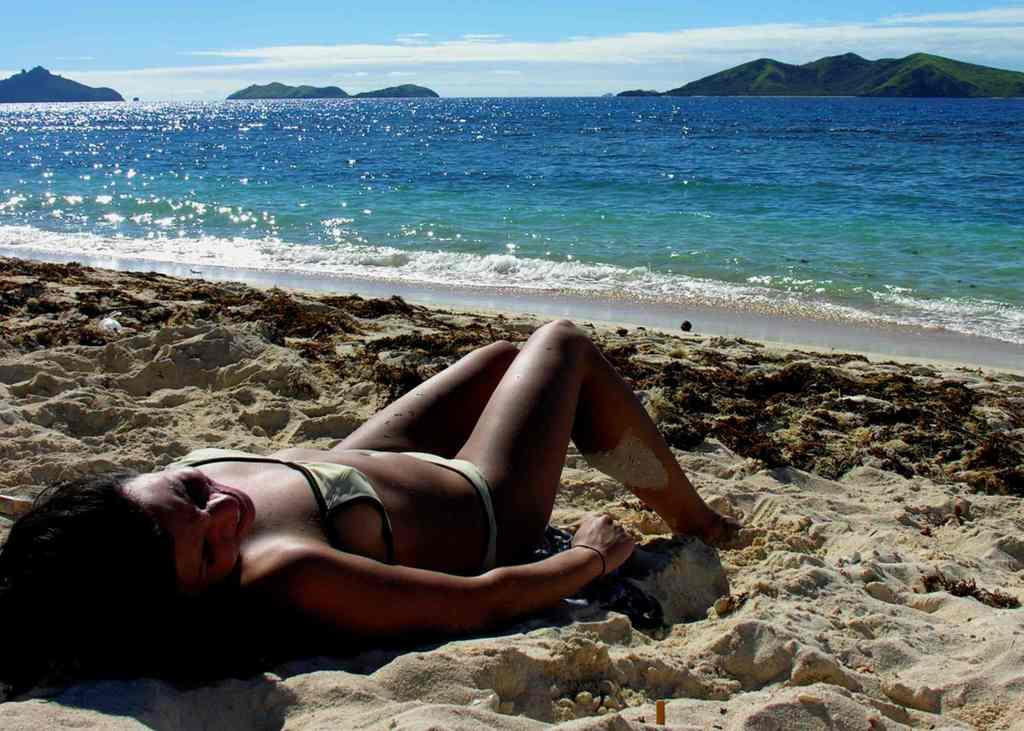Who is present in the image? There is a woman in the image. What is the woman doing in the image? The woman is sleeping. Where is the woman located in the image? The woman is on the sand. What type of environment is the sand located in? The sand is near a beach. What can be seen in the background of the image? There is water visible in the background, and there are mountains in the background. What type of lumber is being used to build a basket in the image? There is no lumber or basket present in the image. How does the woman plan to crush the mountains in the background? The woman is sleeping and not attempting to crush any mountains in the image. 